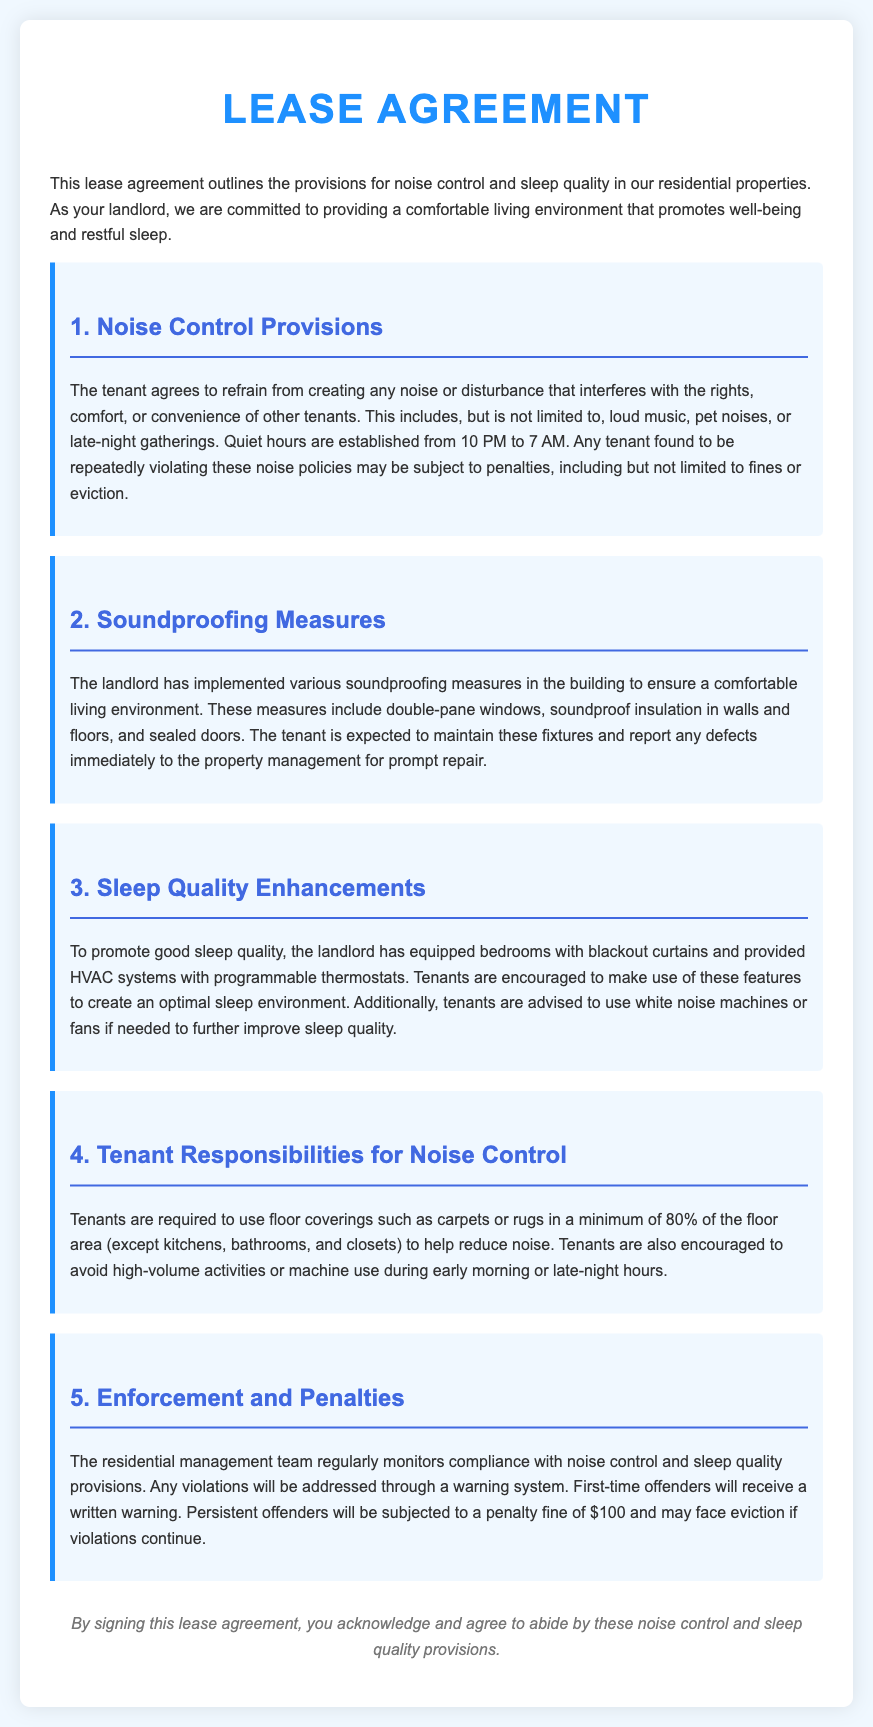What are the quiet hours? The quiet hours are established to ensure a peaceful environment during specific times, defined in the document.
Answer: 10 PM to 7 AM What is the penalty for persistent offenders? The document outlines the consequence for repeated violations, specifically mentioning a financial penalty.
Answer: $100 What should tenants use to help reduce noise? The lease highlights a requirement for tenants to use certain materials to minimize sound disturbance in their premises.
Answer: Carpets or rugs What enhancements are provided to promote good sleep quality? The document lists features specifically included in the bedrooms to improve sleep, showing the landlord's effort to support tenants' rest.
Answer: Blackout curtains Who is responsible for maintaining soundproofing measures? The lease specifies the obligations of tenants regarding the upkeep of certain installations meant for noise control.
Answer: The tenant What will first-time offenders receive? The document mentions a specific action taken by the management team towards tenants who violate the noise control provisions for the first time.
Answer: A written warning What is an additional recommendation for improving sleep quality? The lease suggests an extra tool that tenants might consider using in conjunction with other enhancements to improve their sleep environment.
Answer: White noise machines What are tenants encouraged to avoid during early morning or late-night hours? The document advises against certain activities during specific times to ensure a peaceful atmosphere.
Answer: High-volume activities What does the landlord provide to assist with sleep quality? The lease mentions a specific type of HVAC system feature that contributes to tenants' comfort while sleeping.
Answer: Programmable thermostats 